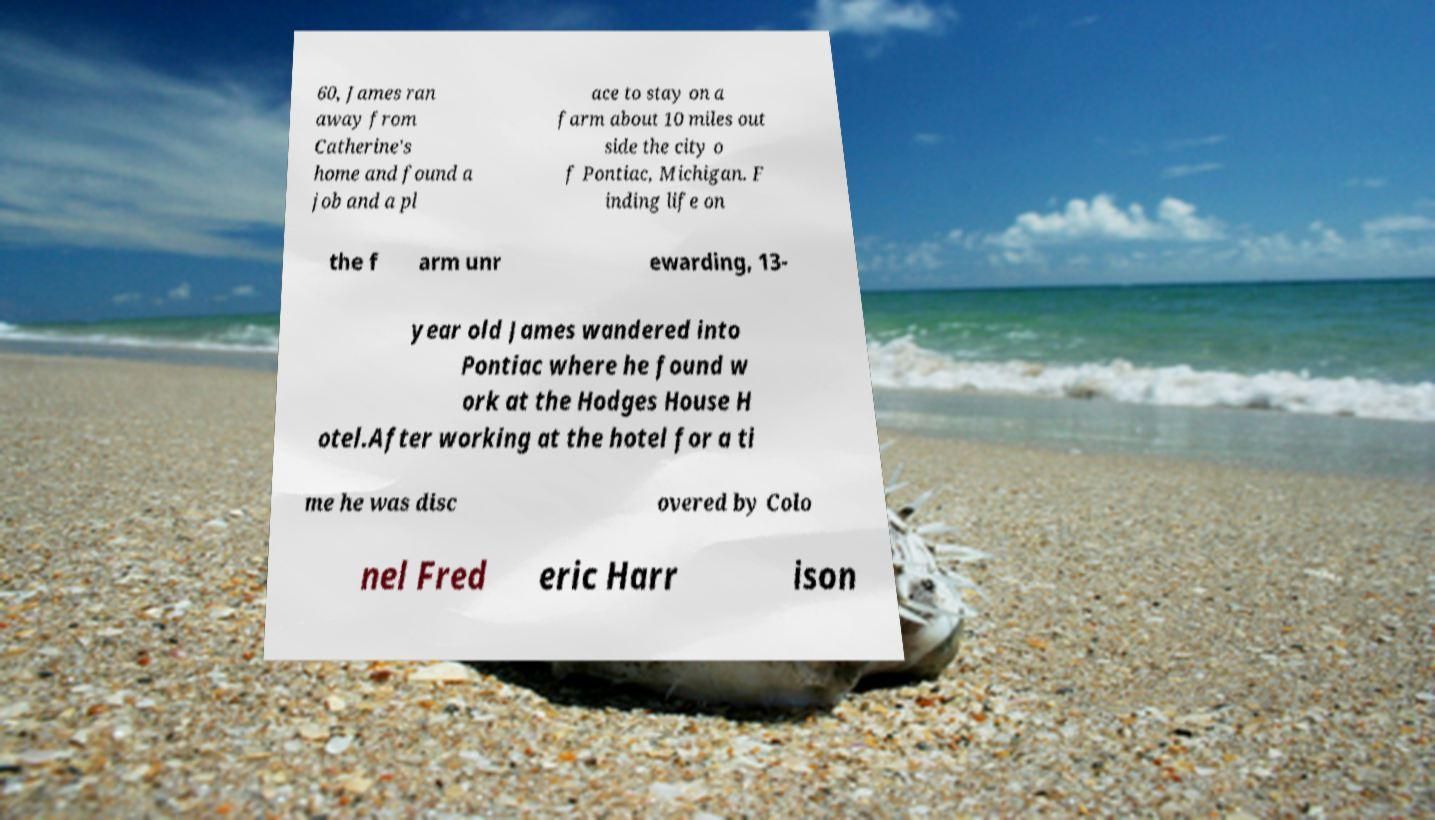Could you extract and type out the text from this image? 60, James ran away from Catherine's home and found a job and a pl ace to stay on a farm about 10 miles out side the city o f Pontiac, Michigan. F inding life on the f arm unr ewarding, 13- year old James wandered into Pontiac where he found w ork at the Hodges House H otel.After working at the hotel for a ti me he was disc overed by Colo nel Fred eric Harr ison 